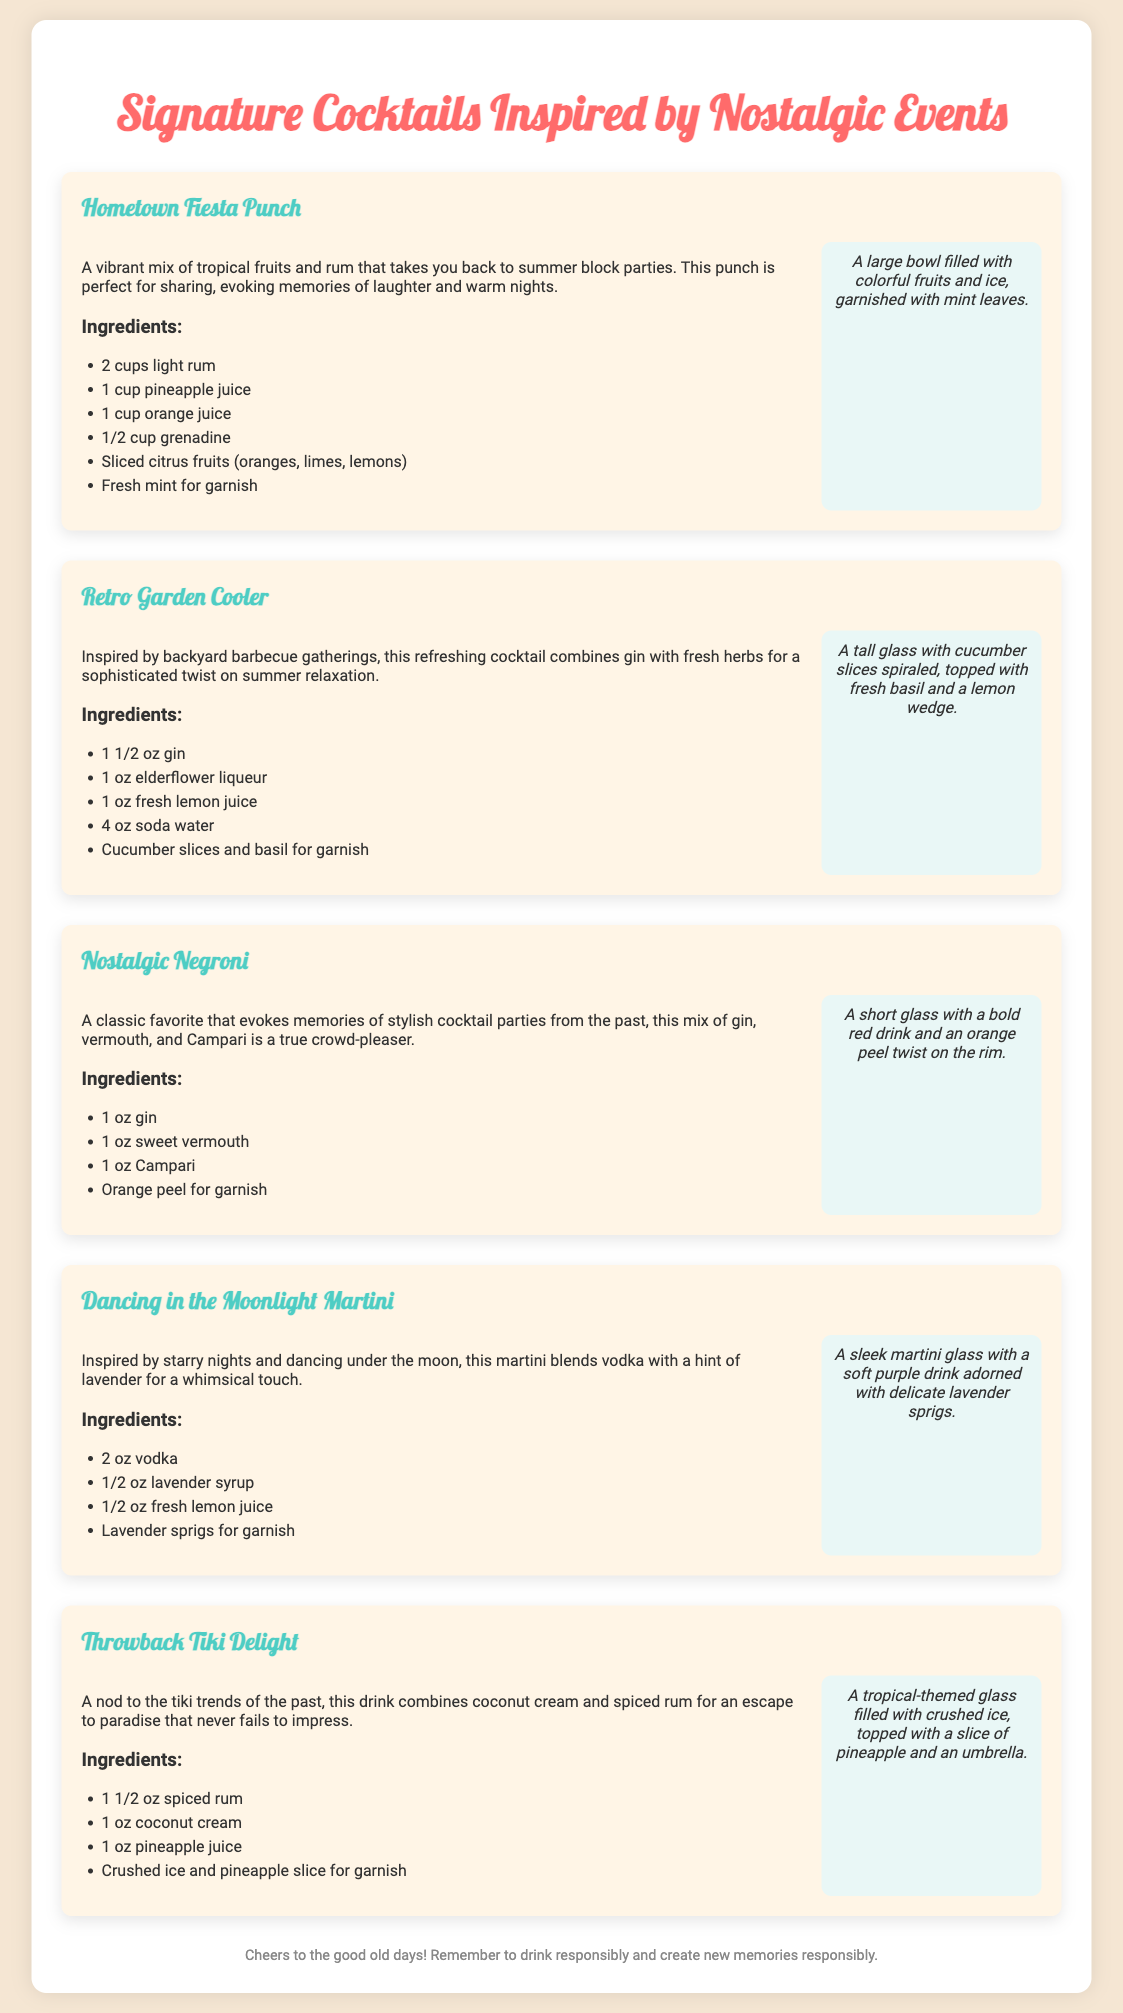what is the first cocktail listed? The first cocktail listed in the document is "Hometown Fiesta Punch."
Answer: Hometown Fiesta Punch how many ingredients are in the Nostalgic Negroni? The Nostalgic Negroni has four listed ingredients.
Answer: 4 which cocktail features lavender? The cocktail that features lavender is "Dancing in the Moonlight Martini."
Answer: Dancing in the Moonlight Martini what type of glass is used for the Dancing in the Moonlight Martini? The description states that a sleek martini glass is used for the Dancing in the Moonlight Martini.
Answer: martini glass what is the garnish for the Throwback Tiki Delight? The garnish for the Throwback Tiki Delight includes a slice of pineapple and an umbrella.
Answer: pineapple slice and an umbrella which cocktail is inspired by backyard barbecue gatherings? The cocktail inspired by backyard barbecue gatherings is "Retro Garden Cooler."
Answer: Retro Garden Cooler how many ounces of gin are required in the Retro Garden Cooler? The Retro Garden Cooler requires 1.5 ounces of gin.
Answer: 1 1/2 oz gin what color is the drink of the Nostalgic Negroni? The drink of the Nostalgic Negroni is described as a bold red drink.
Answer: bold red which cocktail has fresh mint for garnish? The "Hometown Fiesta Punch" has fresh mint for garnish.
Answer: Hometown Fiesta Punch 